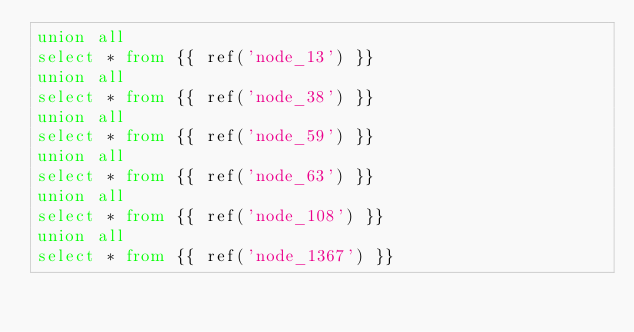<code> <loc_0><loc_0><loc_500><loc_500><_SQL_>union all
select * from {{ ref('node_13') }}
union all
select * from {{ ref('node_38') }}
union all
select * from {{ ref('node_59') }}
union all
select * from {{ ref('node_63') }}
union all
select * from {{ ref('node_108') }}
union all
select * from {{ ref('node_1367') }}
</code> 